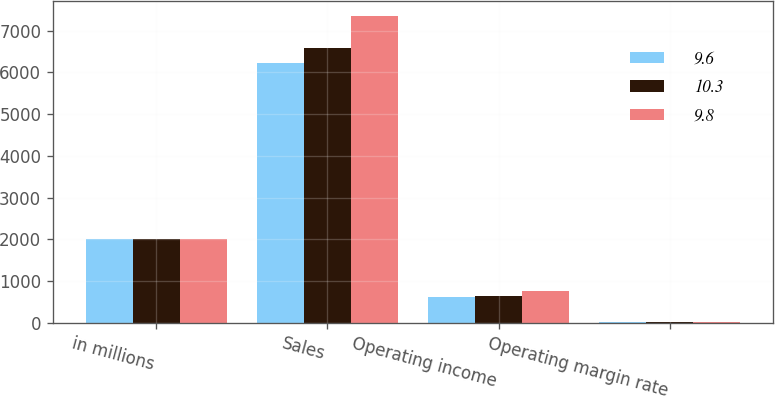Convert chart to OTSL. <chart><loc_0><loc_0><loc_500><loc_500><stacked_bar_chart><ecel><fcel>in millions<fcel>Sales<fcel>Operating income<fcel>Operating margin rate<nl><fcel>9.6<fcel>2014<fcel>6222<fcel>611<fcel>9.8<nl><fcel>10.3<fcel>2013<fcel>6596<fcel>633<fcel>9.6<nl><fcel>9.8<fcel>2012<fcel>7356<fcel>761<fcel>10.3<nl></chart> 